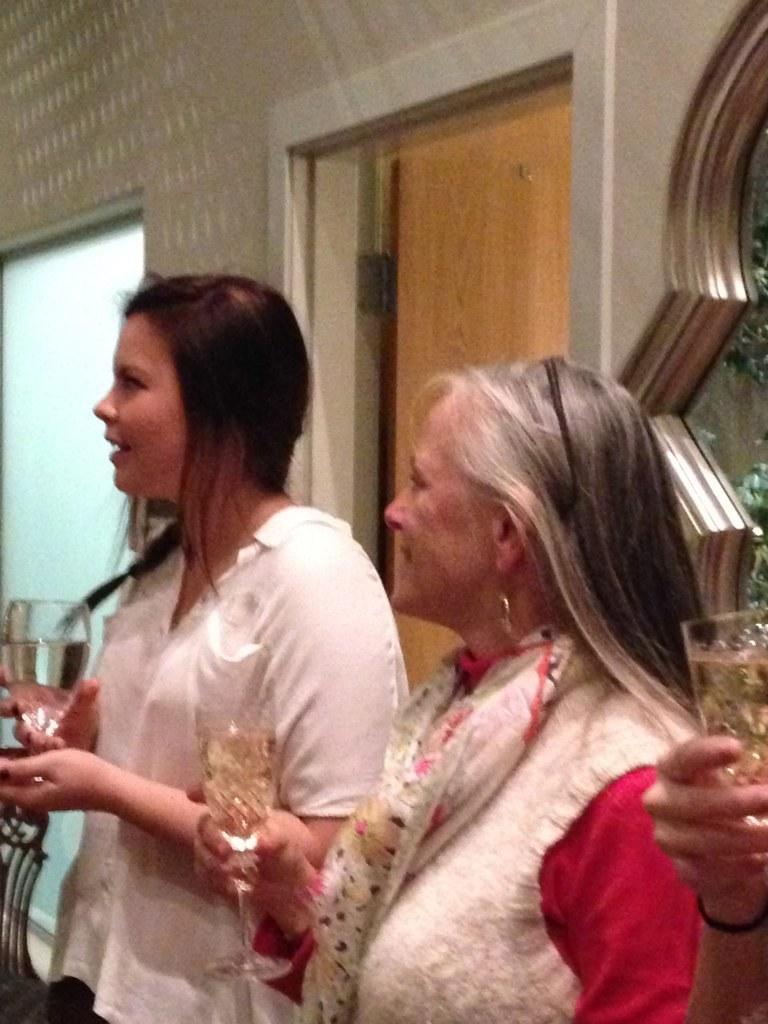Can you describe this image briefly? There are two persons standing and holding a glass in their hands and there is also other person holding a glass in her hands in the right corner and there is a door in the background. 